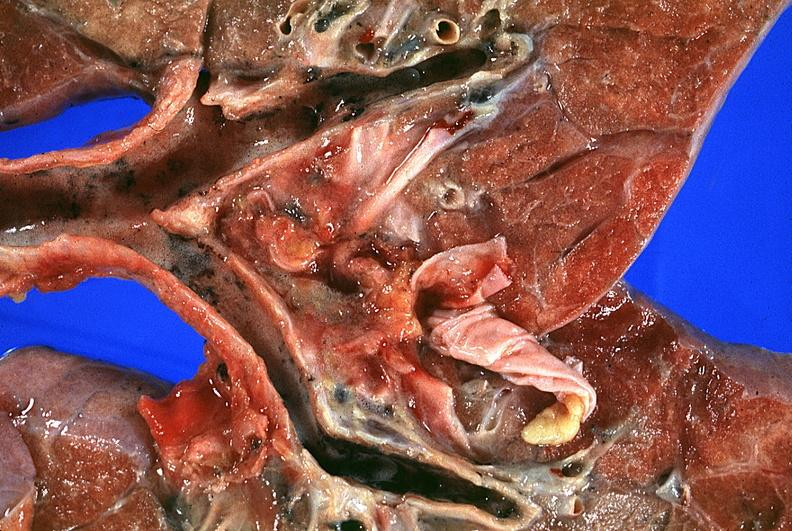what burn smoke inhalation?
Answer the question using a single word or phrase. Thermal 